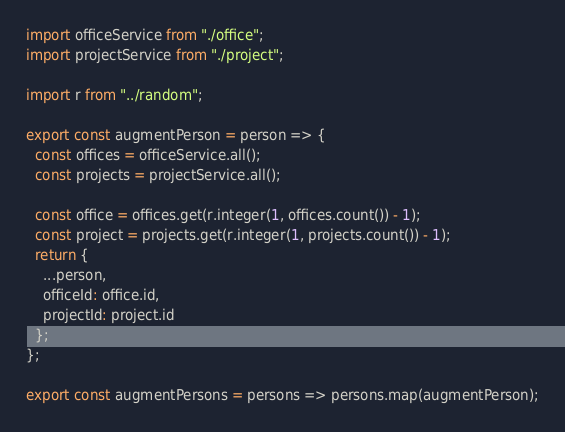<code> <loc_0><loc_0><loc_500><loc_500><_JavaScript_>import officeService from "./office";
import projectService from "./project";

import r from "../random";

export const augmentPerson = person => {
  const offices = officeService.all();
  const projects = projectService.all();

  const office = offices.get(r.integer(1, offices.count()) - 1);
  const project = projects.get(r.integer(1, projects.count()) - 1);
  return {
    ...person,
    officeId: office.id,
    projectId: project.id
  };
};

export const augmentPersons = persons => persons.map(augmentPerson);
</code> 